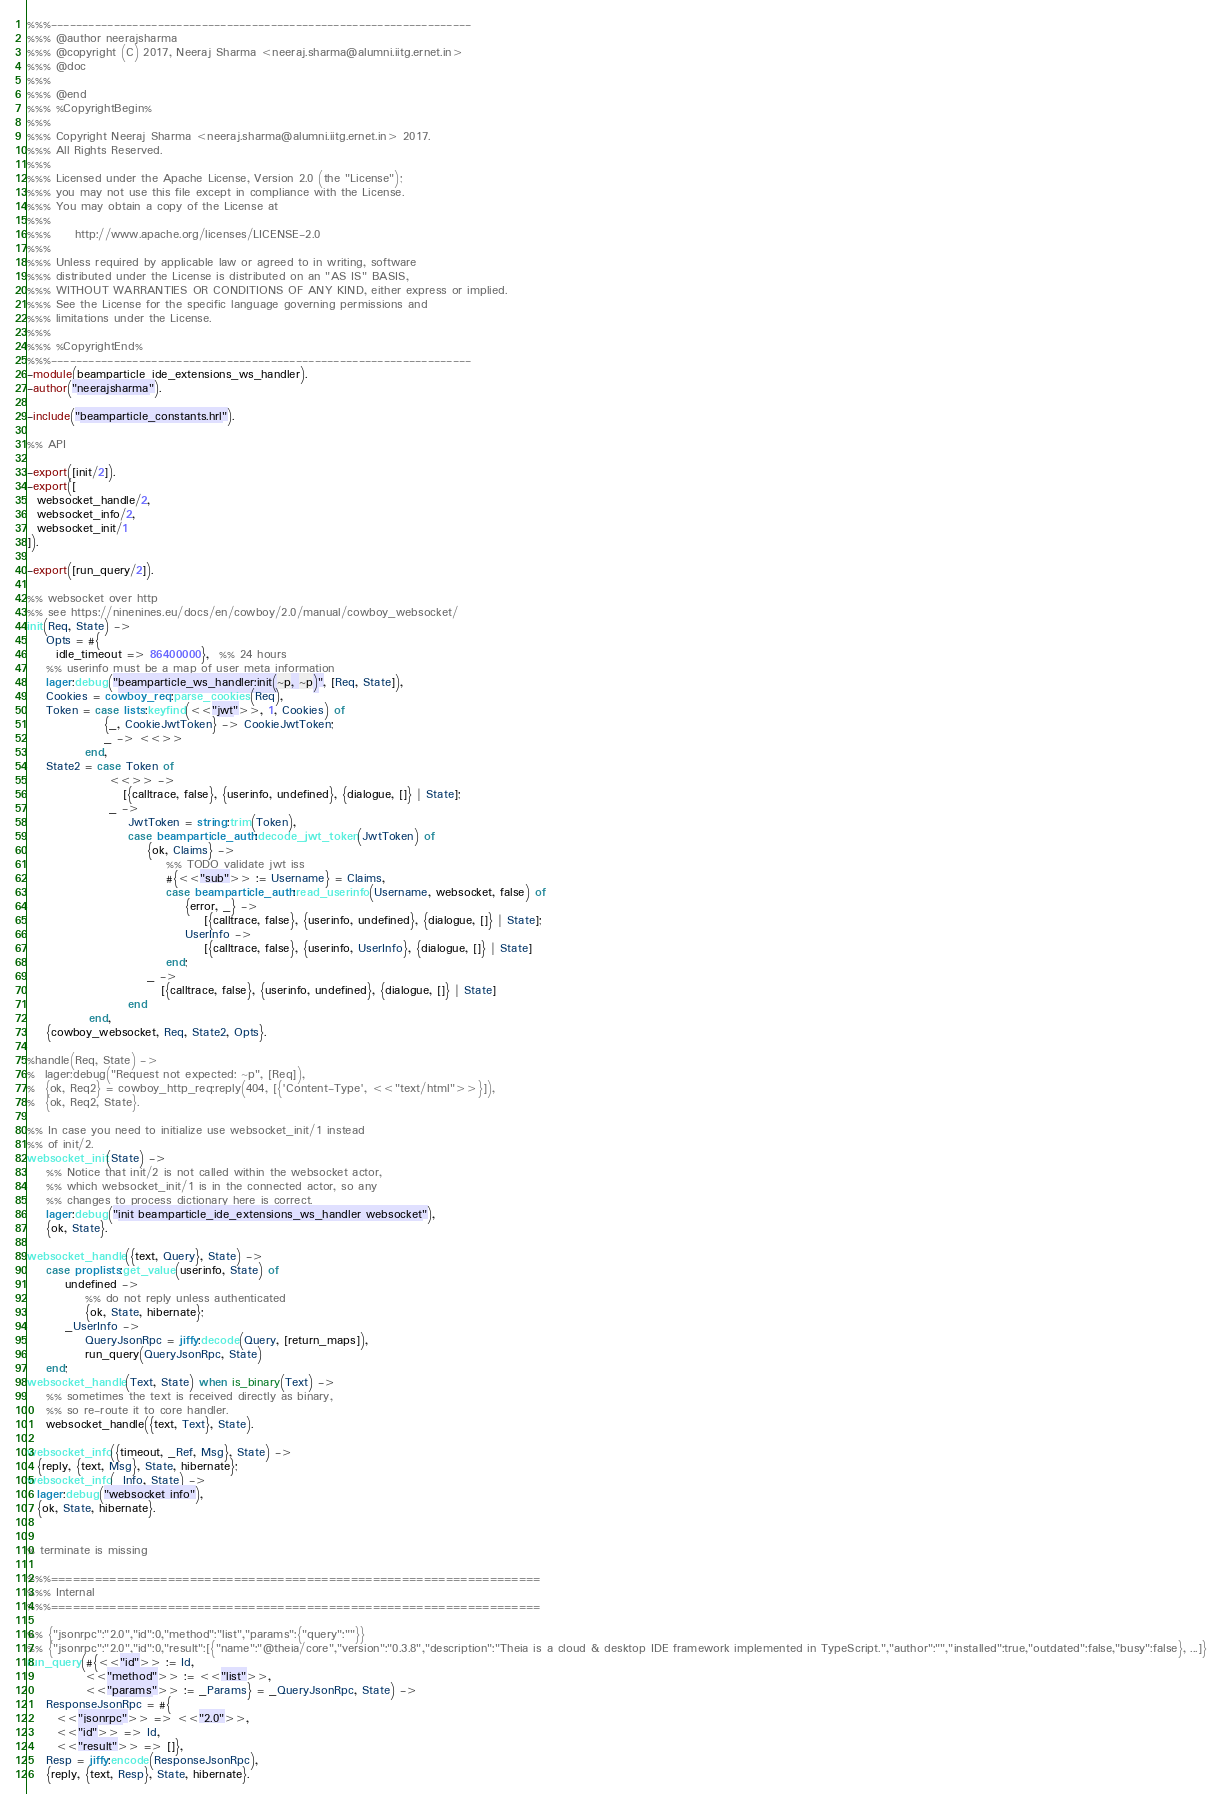Convert code to text. <code><loc_0><loc_0><loc_500><loc_500><_Erlang_>%%%-------------------------------------------------------------------
%%% @author neerajsharma
%%% @copyright (C) 2017, Neeraj Sharma <neeraj.sharma@alumni.iitg.ernet.in>
%%% @doc
%%%
%%% @end
%%% %CopyrightBegin%
%%%
%%% Copyright Neeraj Sharma <neeraj.sharma@alumni.iitg.ernet.in> 2017.
%%% All Rights Reserved.
%%%
%%% Licensed under the Apache License, Version 2.0 (the "License");
%%% you may not use this file except in compliance with the License.
%%% You may obtain a copy of the License at
%%%
%%%     http://www.apache.org/licenses/LICENSE-2.0
%%%
%%% Unless required by applicable law or agreed to in writing, software
%%% distributed under the License is distributed on an "AS IS" BASIS,
%%% WITHOUT WARRANTIES OR CONDITIONS OF ANY KIND, either express or implied.
%%% See the License for the specific language governing permissions and
%%% limitations under the License.
%%%
%%% %CopyrightEnd%
%%%-------------------------------------------------------------------
-module(beamparticle_ide_extensions_ws_handler).
-author("neerajsharma").

-include("beamparticle_constants.hrl").

%% API

-export([init/2]).
-export([
  websocket_handle/2,
  websocket_info/2,
  websocket_init/1
]).

-export([run_query/2]).

%% websocket over http
%% see https://ninenines.eu/docs/en/cowboy/2.0/manual/cowboy_websocket/
init(Req, State) ->
    Opts = #{
      idle_timeout => 86400000},  %% 24 hours
    %% userinfo must be a map of user meta information
    lager:debug("beamparticle_ws_handler:init(~p, ~p)", [Req, State]),
    Cookies = cowboy_req:parse_cookies(Req),
    Token = case lists:keyfind(<<"jwt">>, 1, Cookies) of
                {_, CookieJwtToken} -> CookieJwtToken;
                _ -> <<>>
            end,
    State2 = case Token of
                 <<>> ->
                    [{calltrace, false}, {userinfo, undefined}, {dialogue, []} | State];
                 _ ->
                     JwtToken = string:trim(Token),
                     case beamparticle_auth:decode_jwt_token(JwtToken) of
                         {ok, Claims} ->
                             %% TODO validate jwt iss
                             #{<<"sub">> := Username} = Claims,
                             case beamparticle_auth:read_userinfo(Username, websocket, false) of
                                 {error, _} ->
                                     [{calltrace, false}, {userinfo, undefined}, {dialogue, []} | State];
                                 UserInfo ->
                                     [{calltrace, false}, {userinfo, UserInfo}, {dialogue, []} | State]
                             end;
                         _ ->
                            [{calltrace, false}, {userinfo, undefined}, {dialogue, []} | State]
                     end
             end,
    {cowboy_websocket, Req, State2, Opts}.

%handle(Req, State) ->
%  lager:debug("Request not expected: ~p", [Req]),
%  {ok, Req2} = cowboy_http_req:reply(404, [{'Content-Type', <<"text/html">>}]),
%  {ok, Req2, State}.

%% In case you need to initialize use websocket_init/1 instead
%% of init/2.
websocket_init(State) ->
    %% Notice that init/2 is not called within the websocket actor,
    %% which websocket_init/1 is in the connected actor, so any
    %% changes to process dictionary here is correct.
    lager:debug("init beamparticle_ide_extensions_ws_handler websocket"),
    {ok, State}.

websocket_handle({text, Query}, State) ->
    case proplists:get_value(userinfo, State) of
        undefined ->
            %% do not reply unless authenticated
            {ok, State, hibernate};
        _UserInfo ->
            QueryJsonRpc = jiffy:decode(Query, [return_maps]),
            run_query(QueryJsonRpc, State)
    end;
websocket_handle(Text, State) when is_binary(Text) ->
    %% sometimes the text is received directly as binary,
    %% so re-route it to core handler.
    websocket_handle({text, Text}, State).

websocket_info({timeout, _Ref, Msg}, State) ->
  {reply, {text, Msg}, State, hibernate};
websocket_info(_Info, State) ->
  lager:debug("websocket info"),
  {ok, State, hibernate}.


% terminate is missing

%%%===================================================================
%%% Internal
%%%===================================================================

%% {"jsonrpc":"2.0","id":0,"method":"list","params":{"query":""}}
%% {"jsonrpc":"2.0","id":0,"result":[{"name":"@theia/core","version":"0.3.8","description":"Theia is a cloud & desktop IDE framework implemented in TypeScript.","author":"","installed":true,"outdated":false,"busy":false}, ...]}
run_query(#{<<"id">> := Id,
            <<"method">> := <<"list">>,
            <<"params">> := _Params} = _QueryJsonRpc, State) ->
    ResponseJsonRpc = #{
      <<"jsonrpc">> => <<"2.0">>,
      <<"id">> => Id,
      <<"result">> => []},
    Resp = jiffy:encode(ResponseJsonRpc),
    {reply, {text, Resp}, State, hibernate}.

</code> 